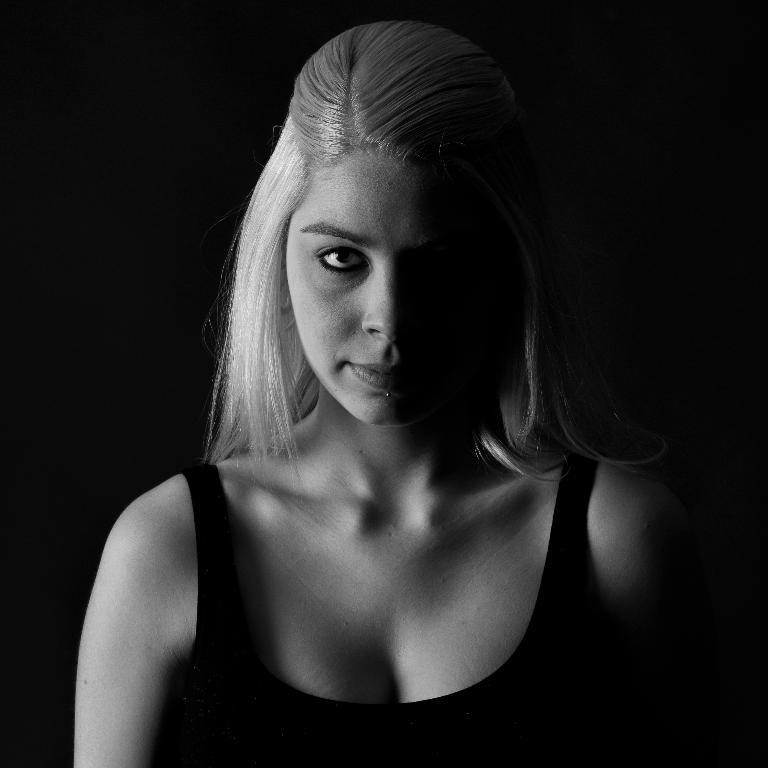What is the color scheme of the image? The image is black and white. Who is present in the image? There is a woman in the image. What is the woman doing in the image? The woman is watching something. What can be seen in the background of the image? The background of the image is dark. What type of stick is the woman holding in the image? There is no stick present in the image. How does the woman's growth affect the image? The woman's growth is not mentioned in the image, and therefore it cannot be determined how it affects the image. 